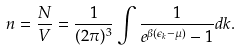<formula> <loc_0><loc_0><loc_500><loc_500>n = \frac { N } { V } = \frac { 1 } { ( 2 \pi ) ^ { 3 } } \int \frac { 1 } { e ^ { \beta ( \epsilon _ { k } - \mu ) } - 1 } d { k } .</formula> 